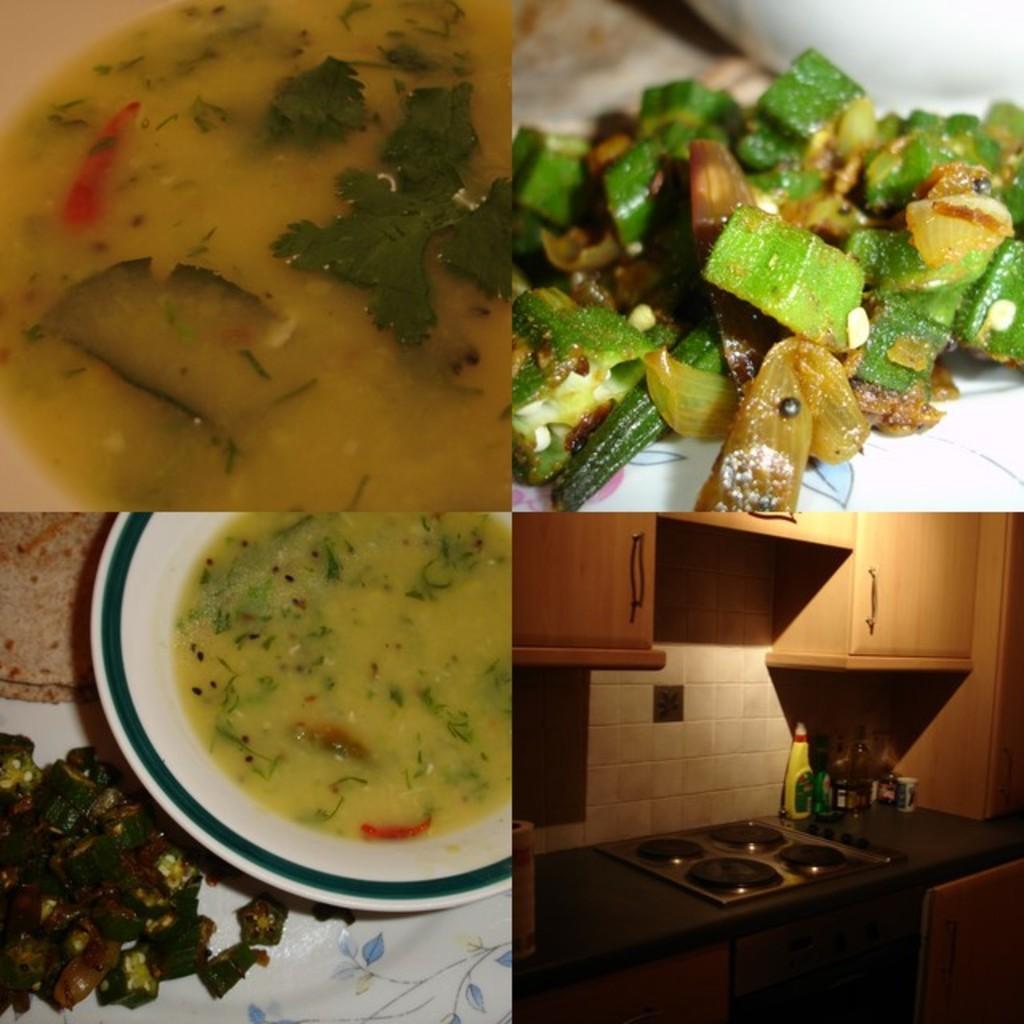Can you describe this image briefly? In this picture I can see there are four different images and there is food placed in bowls and plates. They are placed on a table. 